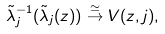Convert formula to latex. <formula><loc_0><loc_0><loc_500><loc_500>\tilde { \lambda } _ { j } ^ { - 1 } ( \tilde { \lambda } _ { j } ( z ) ) \overset { \simeq } \to V ( z , j ) ,</formula> 